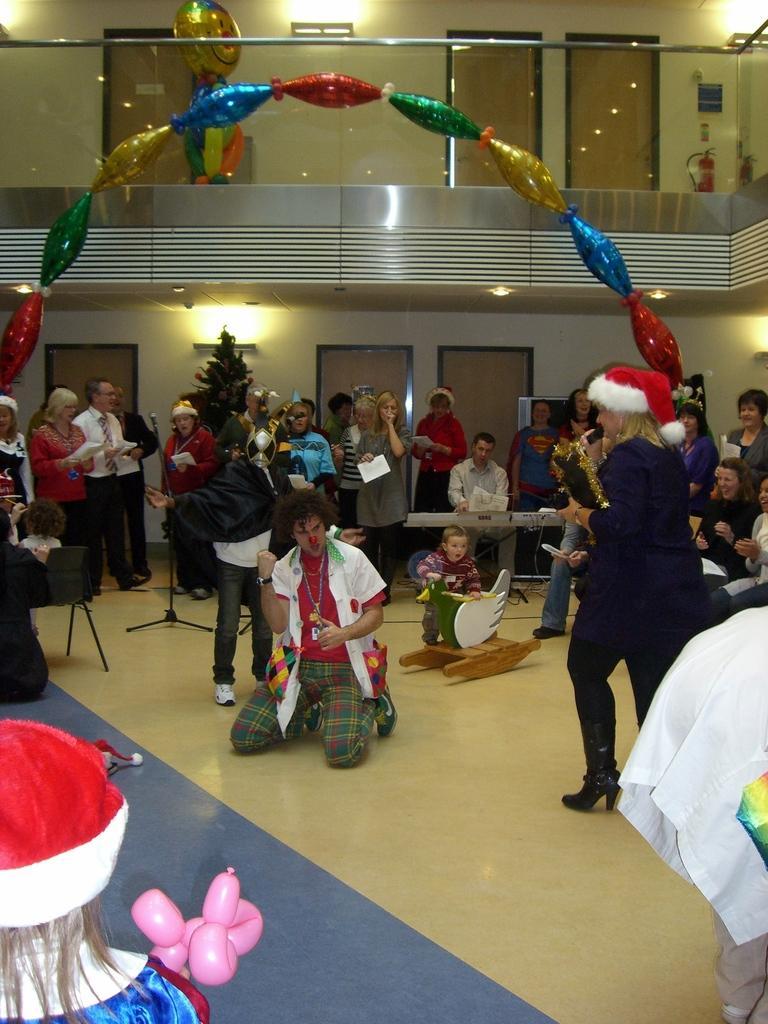Describe this image in one or two sentences. In this image we can see a few people, some of them are sitting and some of them are standing and there are a few balloons, doors, cream color walls, lights and a tree. 